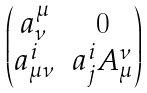Convert formula to latex. <formula><loc_0><loc_0><loc_500><loc_500>\begin{pmatrix} a ^ { \mu } _ { \nu } & 0 \\ a ^ { i } _ { \mu \nu } & a ^ { i } _ { j } A ^ { \nu } _ { \mu } \end{pmatrix}</formula> 